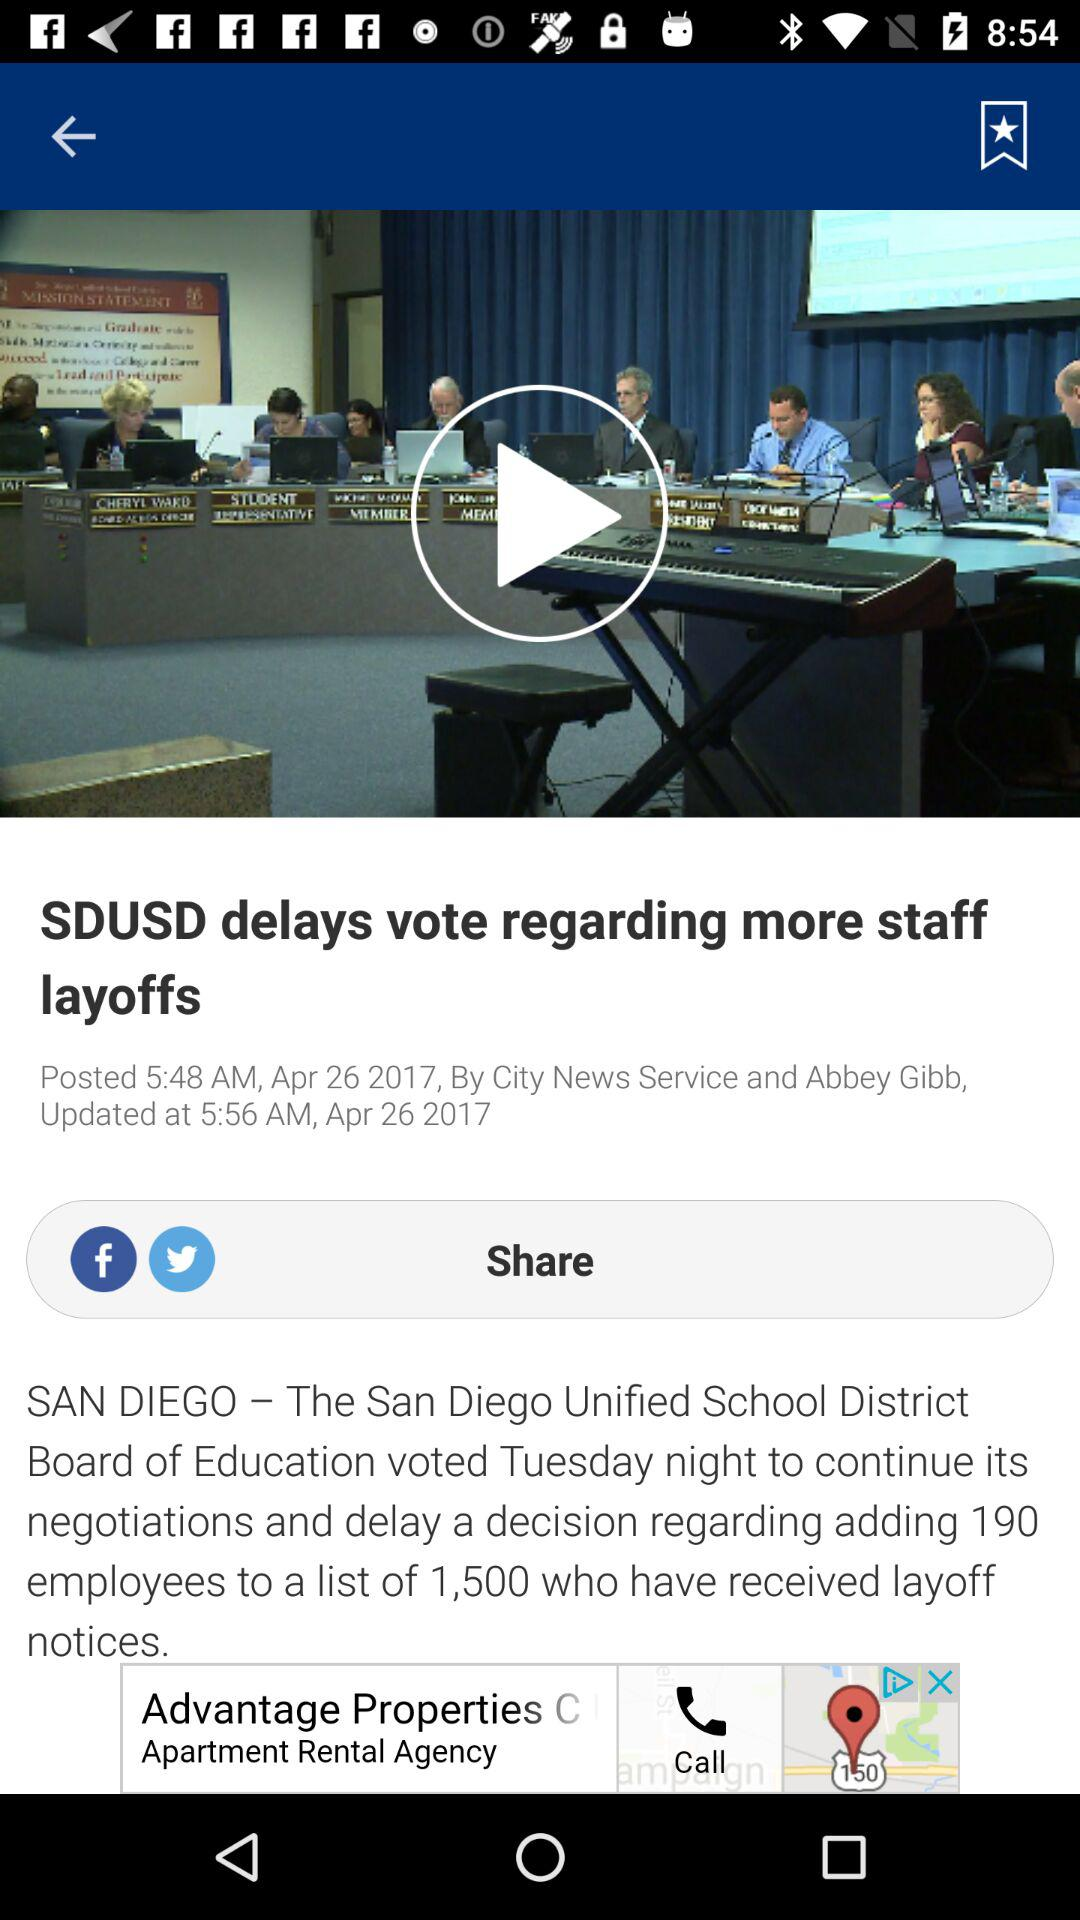What is the name of the author? The name of the author is Abbey Gibb. 